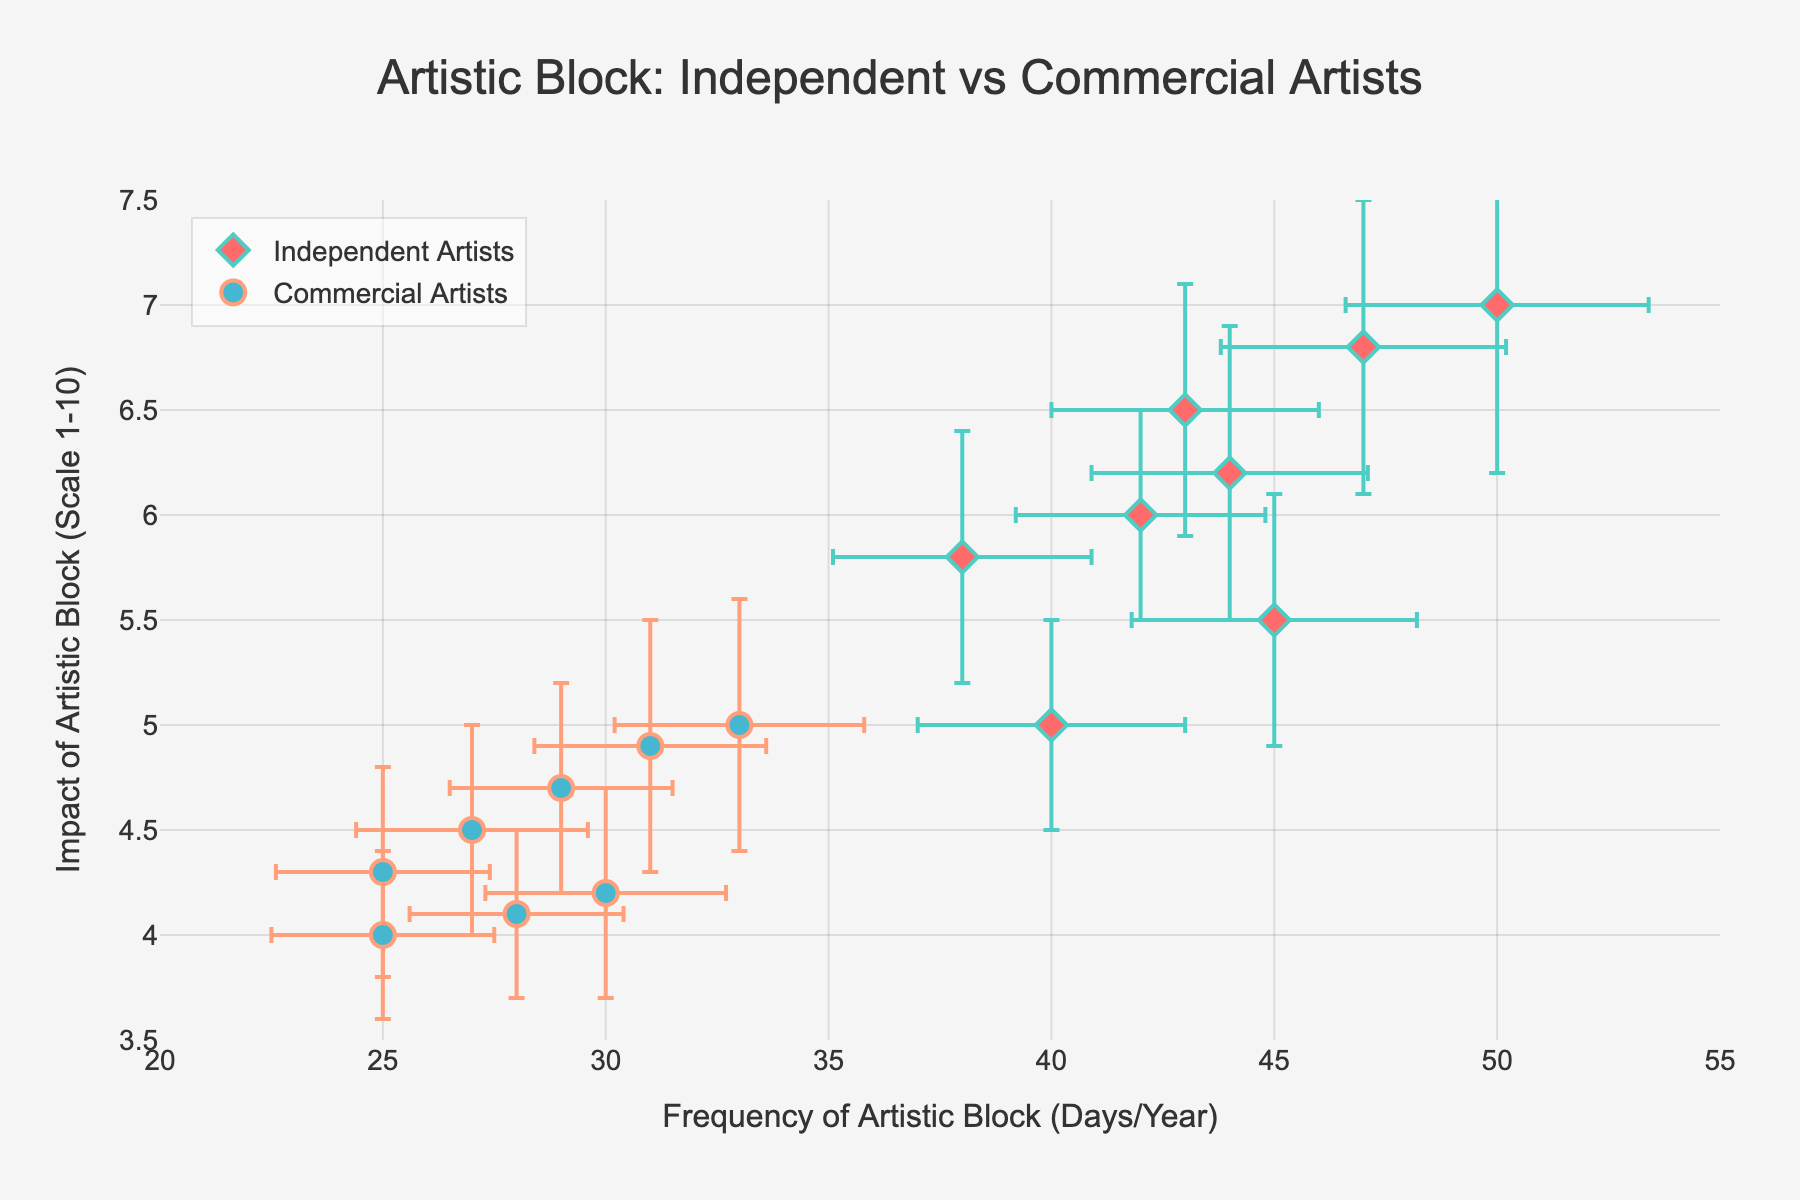What is the title of the figure? The title of the figure is generally found at the top of the chart and summarizes what the figure is about. In this figure, the title is "Artistic Block: Independent vs Commercial Artists".
Answer: Artistic Block: Independent vs Commercial Artists What does the x-axis represent? The x-axis label is provided beneath the horizontal axis, and it tells us what the horizontal values mean. In this figure, the x-axis label is "Frequency of Artistic Block (Days/Year)".
Answer: Frequency of Artistic Block (Days/Year) How many data points are there for Commercial Artists in the year 2016? The data points are marked by symbols on the plot. For the year 2016, there is one marker for Commercial Artists.
Answer: 1 Which category of artists has a higher impact of artistic block generally? Examining the vertical positions (y-axis) of the data points and their average positions can help determine which category generally has higher values. Independent Artists generally have a higher impact of artistic block.
Answer: Independent Artists What symbol and color are used to represent Independent Artists? The symbol and color of the markers are described in the figure’s legend. Independent Artists are represented by a diamond symbol colored red.
Answer: Red diamond In 2020, what was the frequency of artistic block for Commercial Artists, and what was the associated error? By locating the point for Commercial Artists in 2020 on the plot, we see the position along the x-axis and the length of the error bar. The frequency is 29 days/year with an error of 2.5 days/year.
Answer: Frequency 29 days/year, Error 2.5 days/year What's the increase in the impact of artistic block for Independent Artists from 2015 to 2022? Look at the y-value for Independent Artists in 2015 and 2022. In 2015, the impact was 5, and in 2022, it was 7. The increase is 7 - 5 = 2.
Answer: 2 Which category of artists shows a larger variation in the frequency of artistic block based on error bars? By comparing the lengths of error bars, it can be seen that Independent Artists typically have longer error bars, indicating larger variation.
Answer: Independent Artists Is there a trend in the frequency of artistic block for Independent Artists over the years? Observe the x-coordinates of Independent Artists' data points from 2015 to 2022. The points generally show an increasing trend in frequency over the years.
Answer: Increasing trend In which year did Commercial Artists experience the lowest impact of artistic block? By checking the y-values of all the points for Commercial Artists, the lowest impact (4) occurred in 2015.
Answer: 2015 